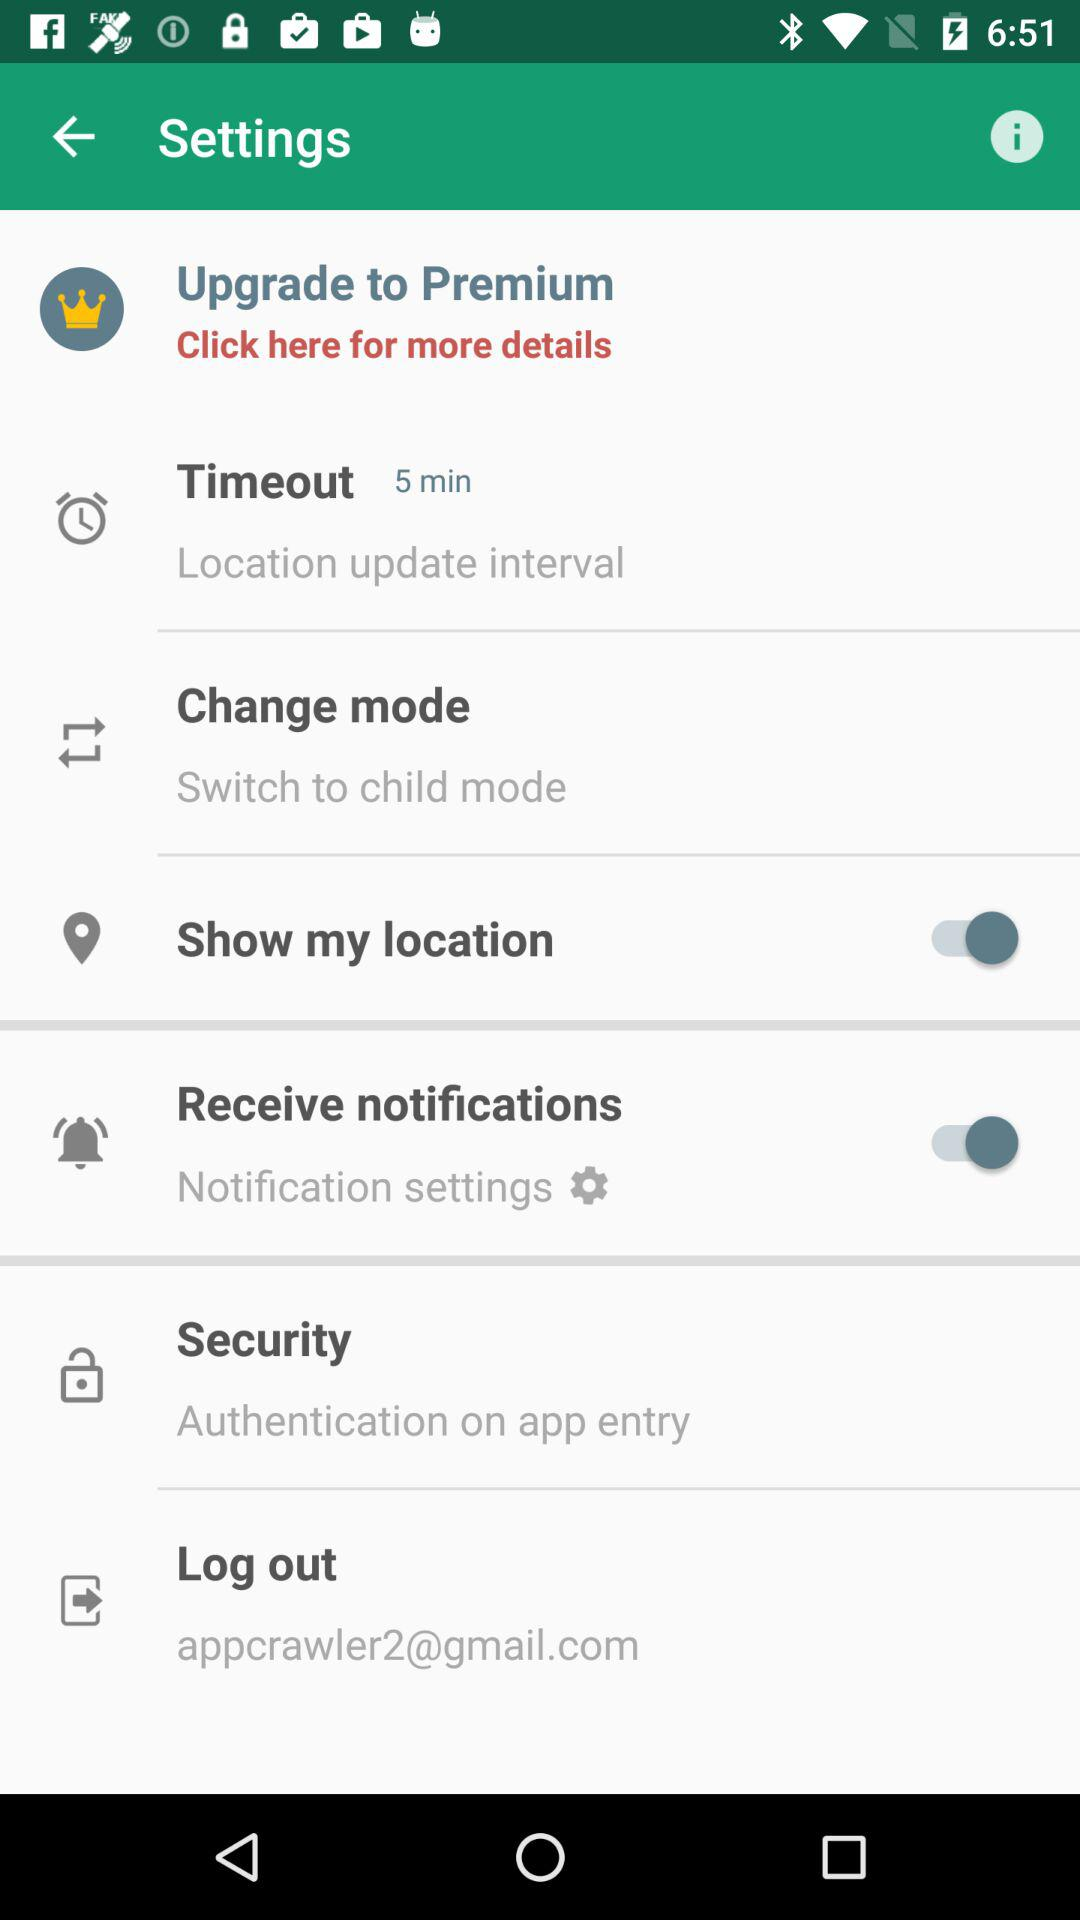What is the "Timeout" interval? The "Timeout" interval is 5 minutes. 